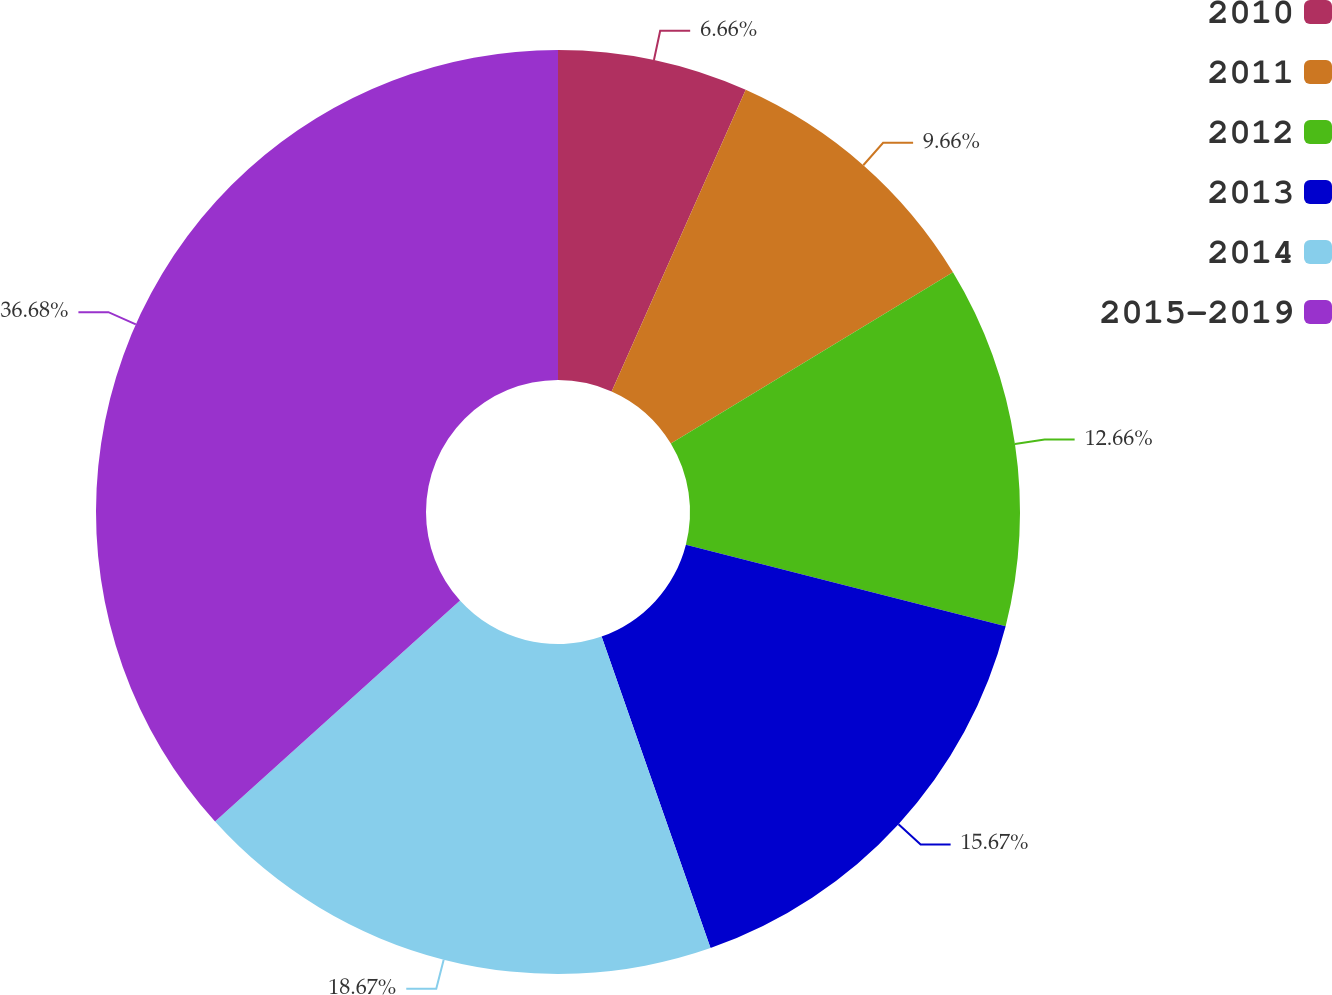Convert chart to OTSL. <chart><loc_0><loc_0><loc_500><loc_500><pie_chart><fcel>2010<fcel>2011<fcel>2012<fcel>2013<fcel>2014<fcel>2015-2019<nl><fcel>6.66%<fcel>9.66%<fcel>12.66%<fcel>15.67%<fcel>18.67%<fcel>36.69%<nl></chart> 